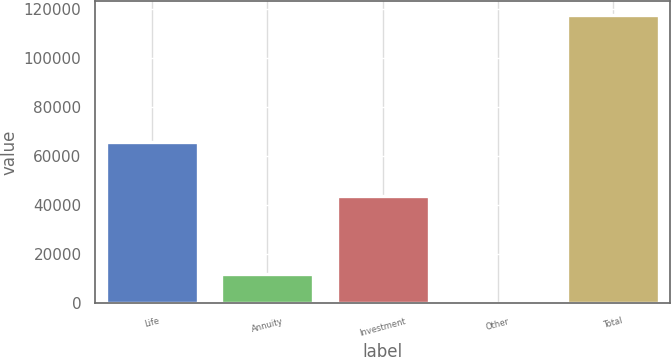Convert chart to OTSL. <chart><loc_0><loc_0><loc_500><loc_500><bar_chart><fcel>Life<fcel>Annuity<fcel>Investment<fcel>Other<fcel>Total<nl><fcel>65726<fcel>11849.2<fcel>43787<fcel>103<fcel>117565<nl></chart> 